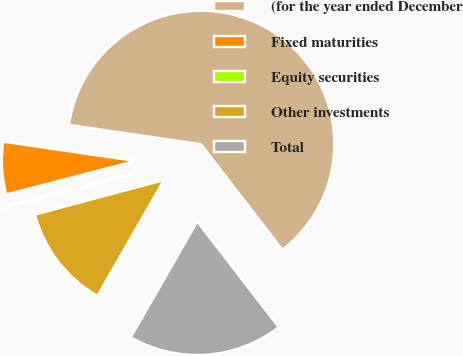Convert chart to OTSL. <chart><loc_0><loc_0><loc_500><loc_500><pie_chart><fcel>(for the year ended December<fcel>Fixed maturities<fcel>Equity securities<fcel>Other investments<fcel>Total<nl><fcel>62.24%<fcel>6.34%<fcel>0.12%<fcel>12.55%<fcel>18.76%<nl></chart> 